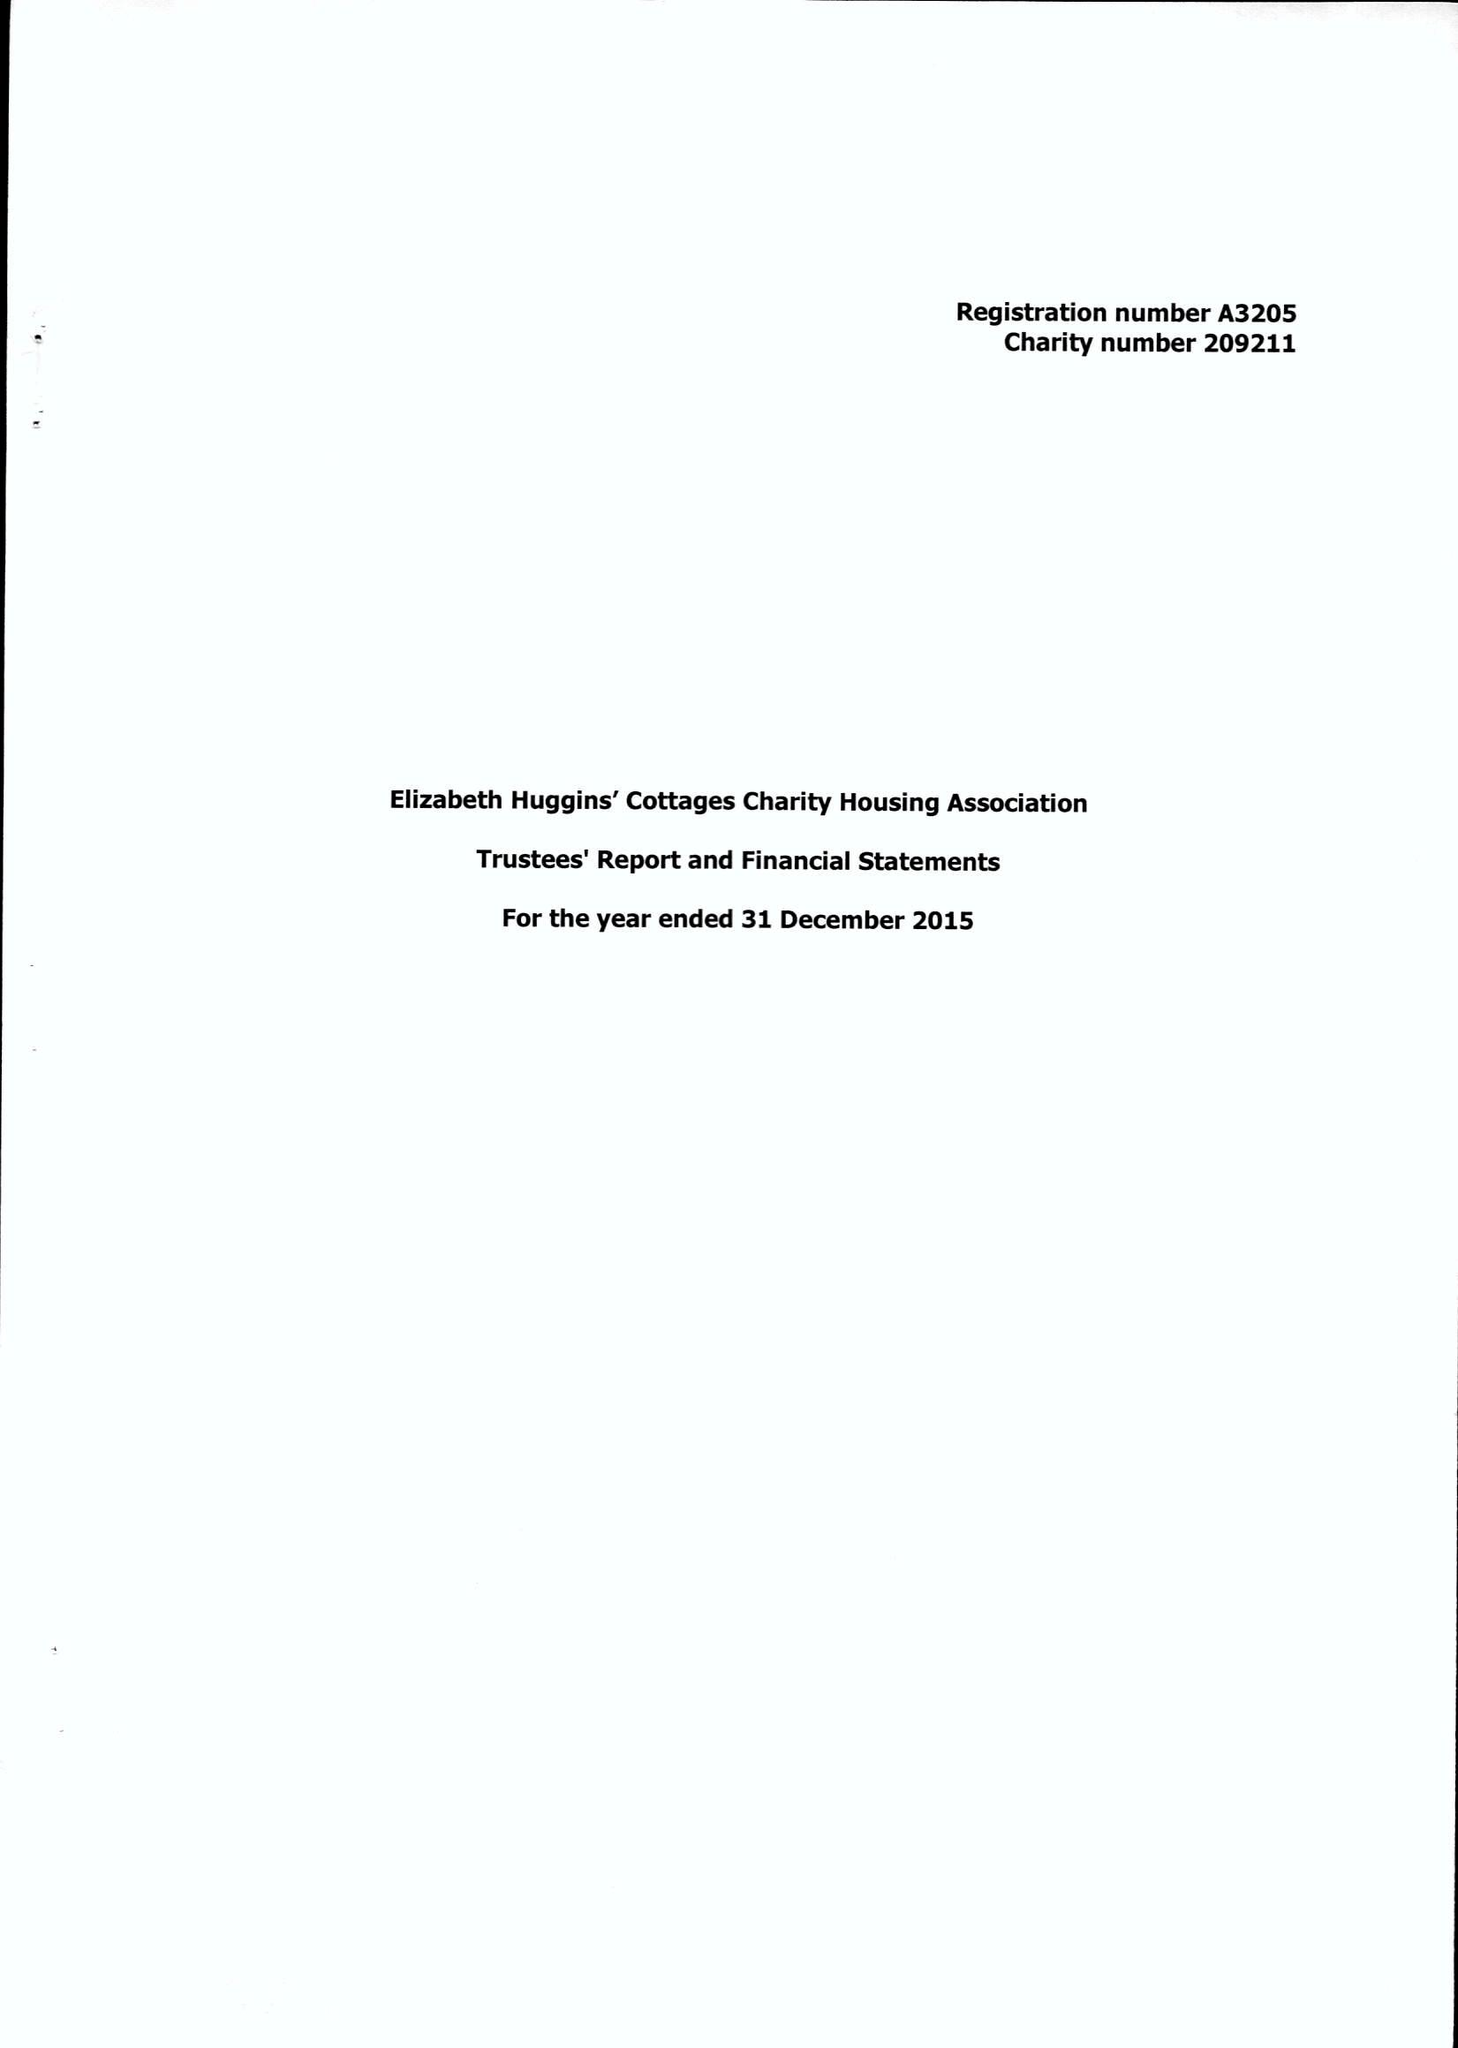What is the value for the report_date?
Answer the question using a single word or phrase. 2015-12-31 